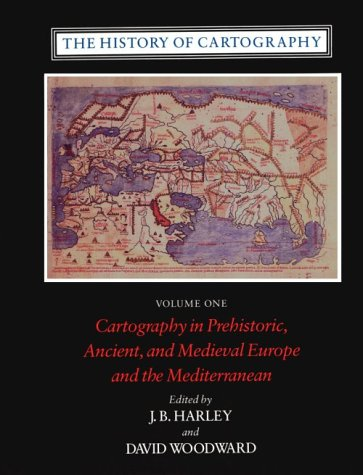How might this book be useful to modern cartographers? This book provides modern cartographers with a nuanced understanding of the evolution of map-making, allowing them to appreciate the historical developments and methods that shaped current practices. Insights from the past can inspire innovative techniques and applications in contemporary projects. 